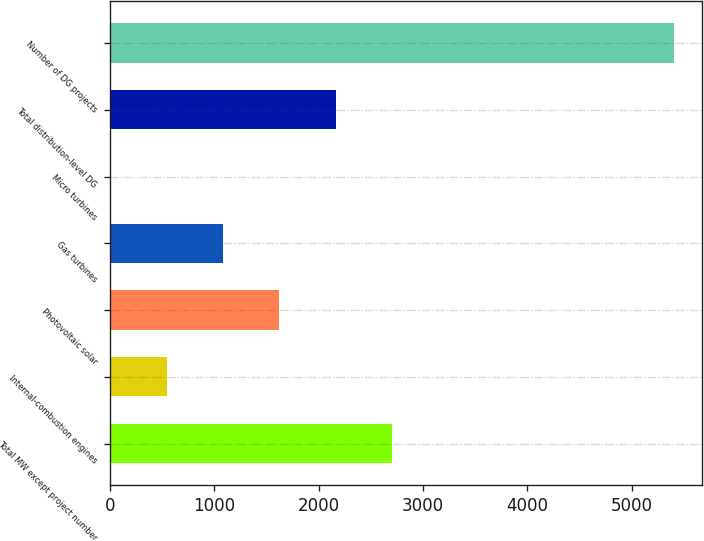<chart> <loc_0><loc_0><loc_500><loc_500><bar_chart><fcel>Total MW except project number<fcel>Internal-combustion engines<fcel>Photovoltaic solar<fcel>Gas turbines<fcel>Micro turbines<fcel>Total distribution-level DG<fcel>Number of DG projects<nl><fcel>2705<fcel>541.8<fcel>1623.4<fcel>1082.6<fcel>1<fcel>2164.2<fcel>5409<nl></chart> 